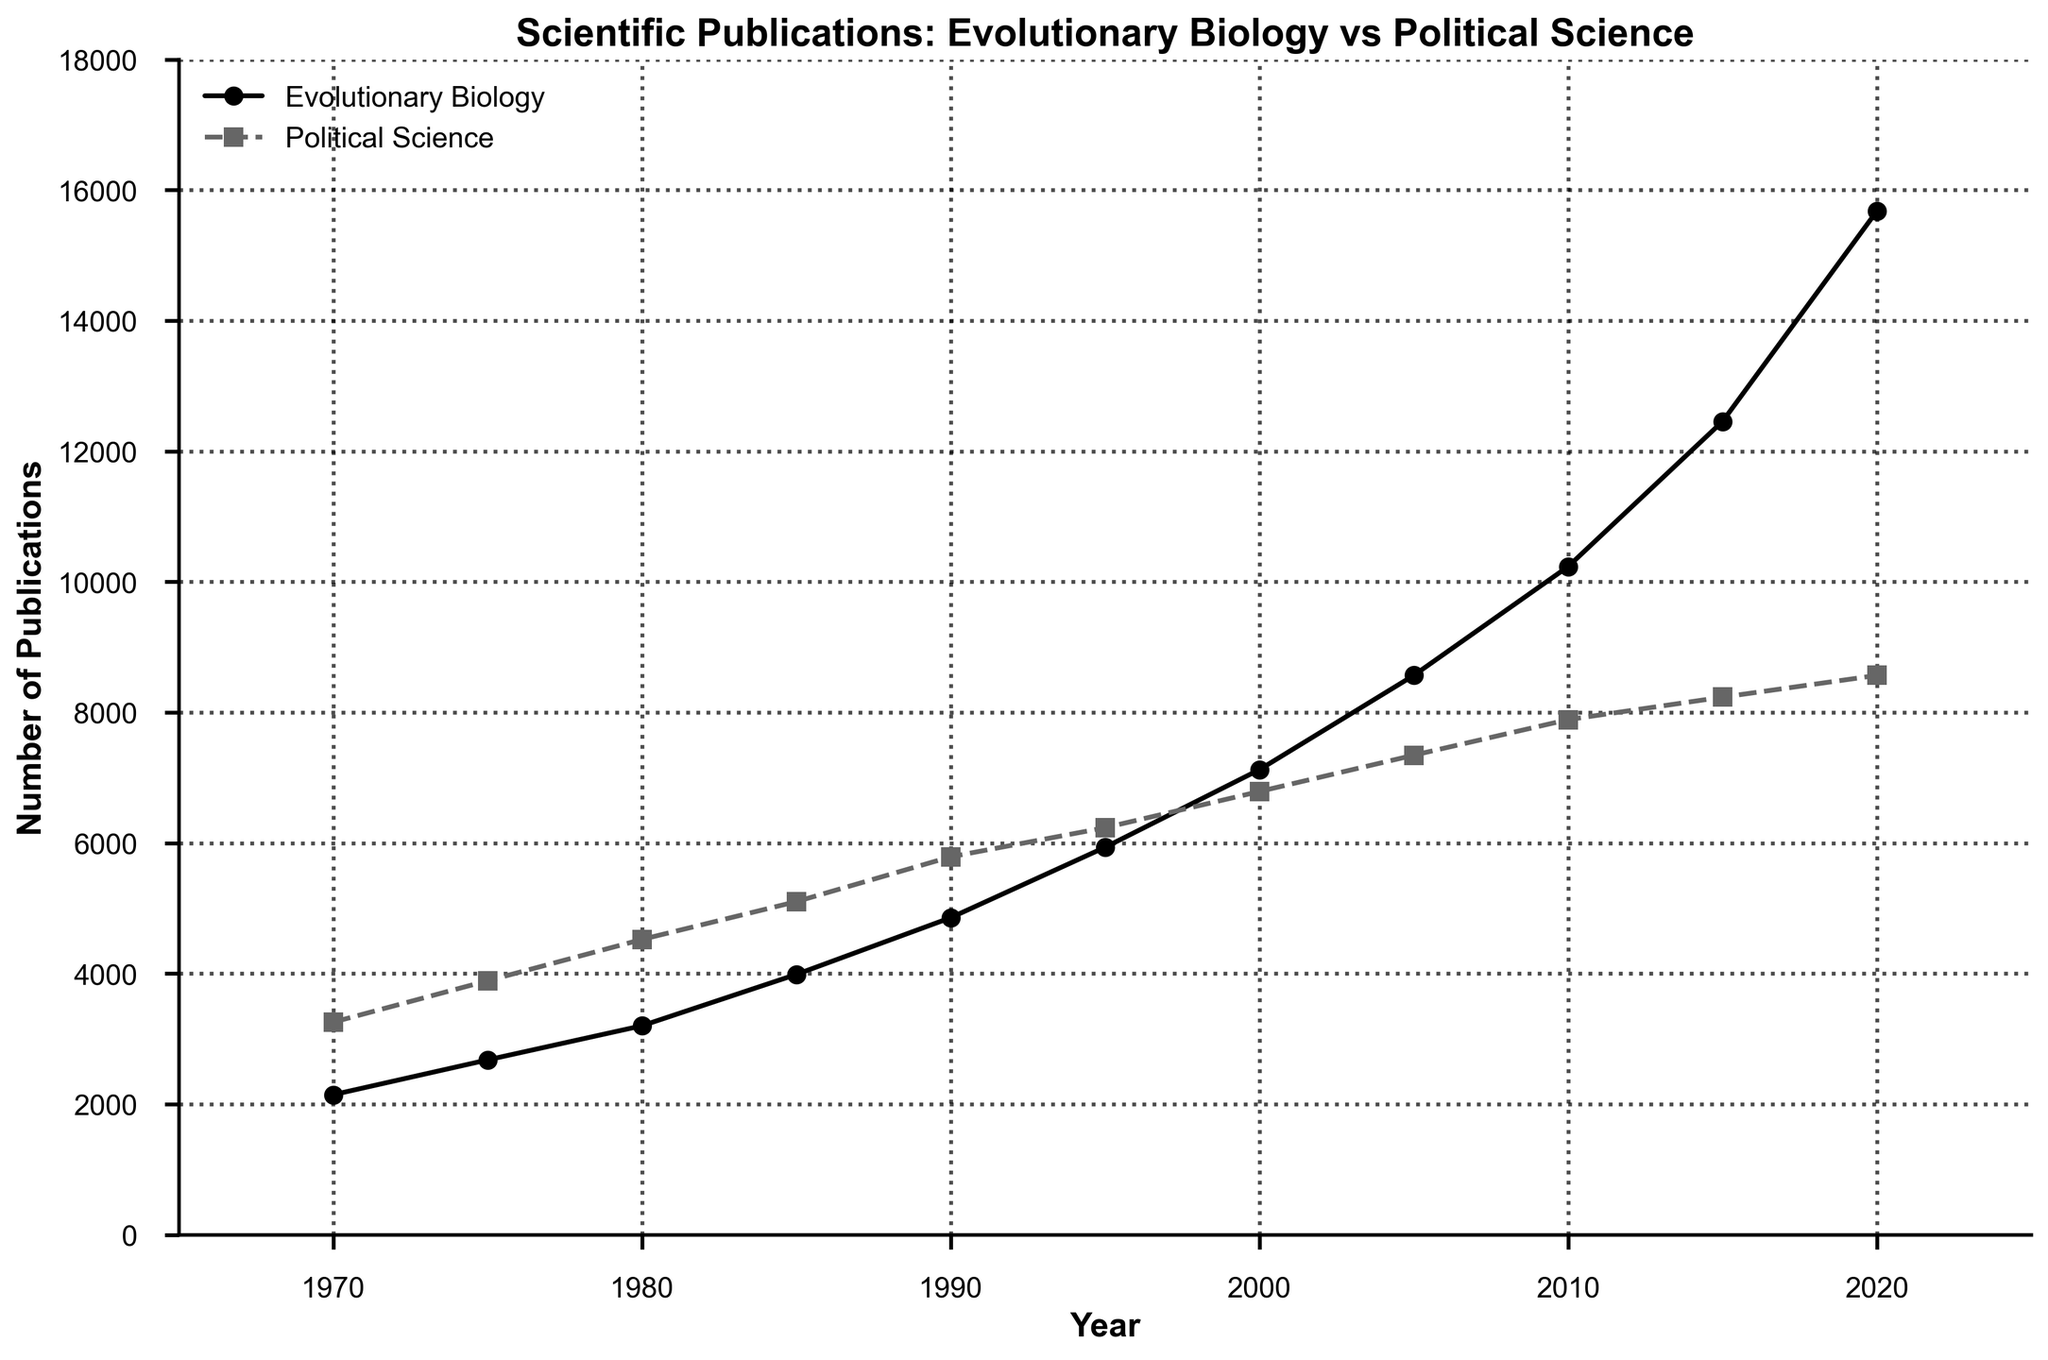What is the difference in the number of Evolutionary Biology Publications between 1980 and 2000? To find the difference, subtract the number of publications in 1980 from the number of publications in 2000. This is: 7123 - 3201 = 3922
Answer: 3922 In which year did Evolutionary Biology Publications surpass Political Science Publications for the first time? By looking at the graph, we notice the lines for Evolutionary Biology and Political Science intersect between 2000 and 2005. In 2005, Evolutionary Biology Publications (8567) surpass Political Science Publications (7345).
Answer: 2005 Which field had a steeper increase in the number of publications from 1990 to 2000? First, calculate the increase for each field from 1990 to 2000. Evolutionary Biology increased from 4856 to 7123, so 7123 - 4856 = 2267. Political Science increased from 5789 to 6789, so 6789 - 5789 = 1000. Evolutionary Biology had a steeper increase.
Answer: Evolutionary Biology What is the average number of Political Science Publications over the 50-year period shown? The total number of Political Science Publications over the years listed is: 3256 + 3890 + 4523 + 5102 + 5789 + 6234 + 6789 + 7345 + 7890 + 8234 + 8567 = 62619. There are 11 data points, so the average is 62619 / 11 = 5692.
Answer: 5692 In which decade did Evolutionary Biology Publications see the most significant growth? To determine the decade with the most significant growth, we calculate the differences by decade:
- 1970-1980: 3201 - 2145 = 1056
- 1980-1990: 4856 - 3201 = 1655
- 1990-2000: 7123 - 4856 = 2267
- 2000-2010: 10234 - 7123 = 3111
- 2010-2020: 15678 - 10234 = 5444
The decade 2010-2020 had the most significant growth.
Answer: 2010-2020 Which field had a higher number of publications in 2015? By observing the graph, Evolutionary Biology had 12456 publications and Political Science had 8234 publications in 2015. Evolutionary Biology had a higher number of publications.
Answer: Evolutionary Biology By how much did the number of Political Science Publications increase from 1970 to 2020? To find the increase, subtract the number of publications in 1970 from that in 2020. This is 8567 - 3256 = 5311
Answer: 5311 What is the visual difference in the styles of the lines representing Evolutionary Biology and Political Science? The line representing Evolutionary Biology is a solid line with circular markers, while the line for Political Science is a dashed line with square markers.
Answer: Solid line and circular markers vs dashed line and square markers What was the combined total number of publications in both fields in 1995? Add the number of publications in each field in 1995. This is 5934 (Evolutionary Biology) + 6234 (Political Science) = 12168
Answer: 12168 How did the relative growth rates of publications in Evolutionary Biology and Political Science compare from 1970 to 2020? Calculate the growth rate for each field. 
- Evolutionary Biology: (15678 - 2145) / 2145 ≈ 6.31 times 
- Political Science: (8567 - 3256) / 3256 ≈ 1.63 times 
The growth rate of Evolutionary Biology was significantly higher than that of Political Science.
Answer: Evolutionary Biology grew faster 